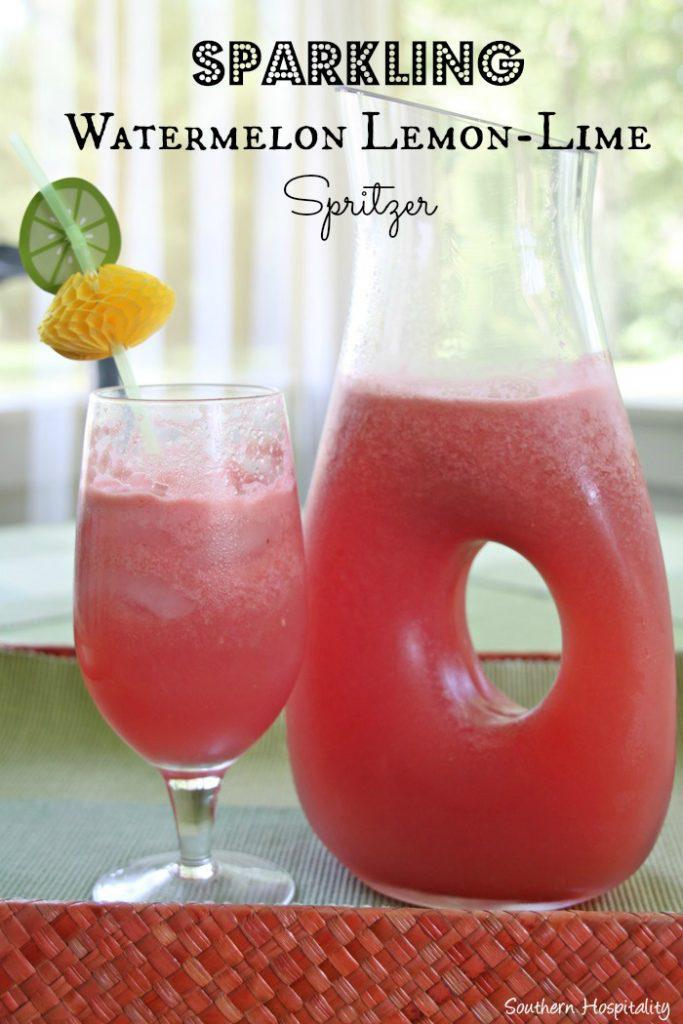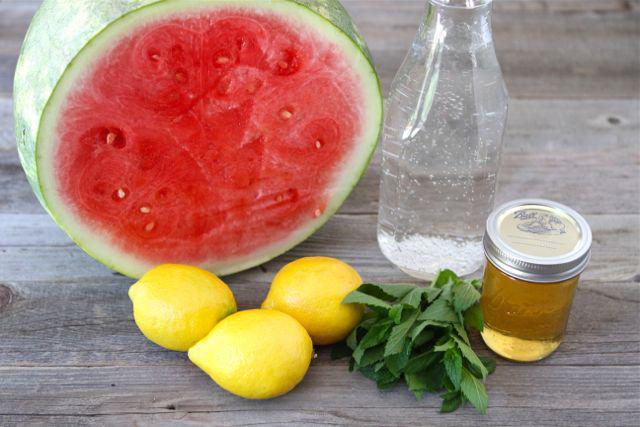The first image is the image on the left, the second image is the image on the right. For the images shown, is this caption "An image includes a serving pitcher and a garnished drink." true? Answer yes or no. Yes. The first image is the image on the left, the second image is the image on the right. For the images shown, is this caption "There are three whole lemons in one of the images." true? Answer yes or no. Yes. 